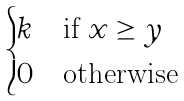Convert formula to latex. <formula><loc_0><loc_0><loc_500><loc_500>\begin{cases} k & \text {if $x \geq y$} \\ 0 & \text {otherwise} \end{cases}</formula> 